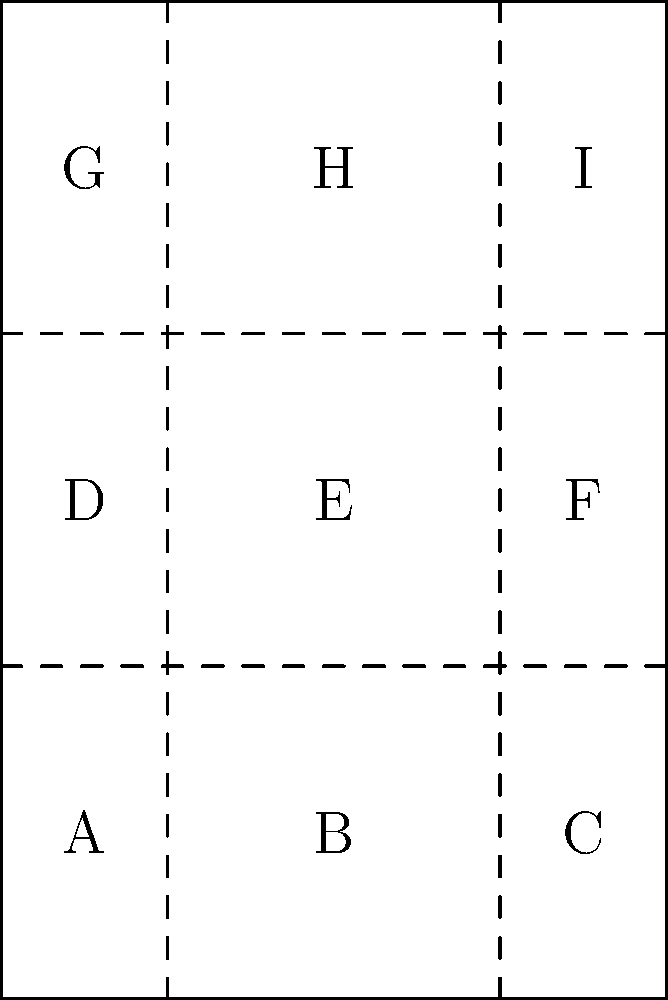You're at the food bank, and they've given you a flat paper grocery bag with folding lines as shown in the diagram. If you fold the bag along these lines to create a compact shape, which section will be on top when the bag is completely folded? Let's follow the folding process step-by-step:

1. The bag is divided into 9 sections (A to I) by the folding lines.
2. First, we fold the left and right sides inward:
   - Section C folds over B
   - Section A folds over B
   - Now B is on top, with A and C underneath
3. Next, we fold the bottom up:
   - Sections A, B, and C (now stacked) fold up over D, E, and F
   - E is now on top, with B directly underneath
4. Finally, we fold the top down:
   - Sections G, H, and I fold down over the stack
   - H is now on top of the entire folded bag

Throughout this process, we're keeping in mind that each fold creates a new layer, with the outermost section becoming the top of the stack after each fold.
Answer: H 